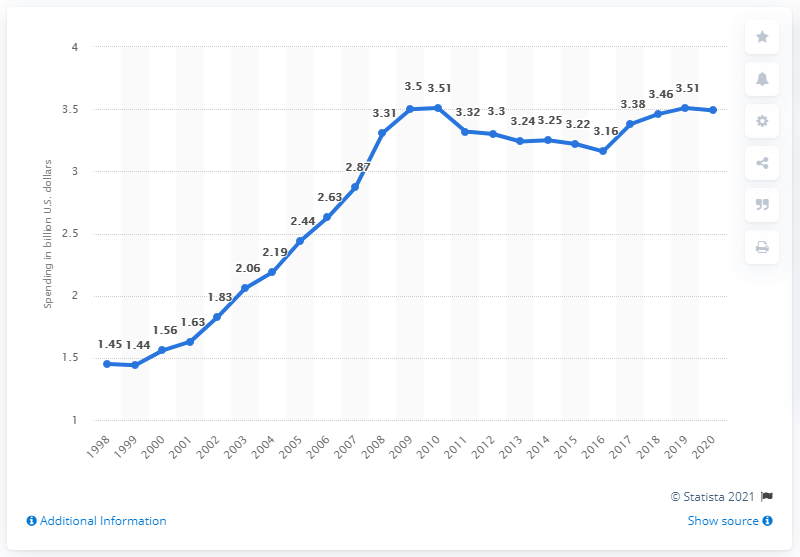Point out several critical features in this image. In 2019, a total of $3.49 was spent on lobbying. The total amount of lobbying spending in the United States in 2020 was 3.49 million dollars. 